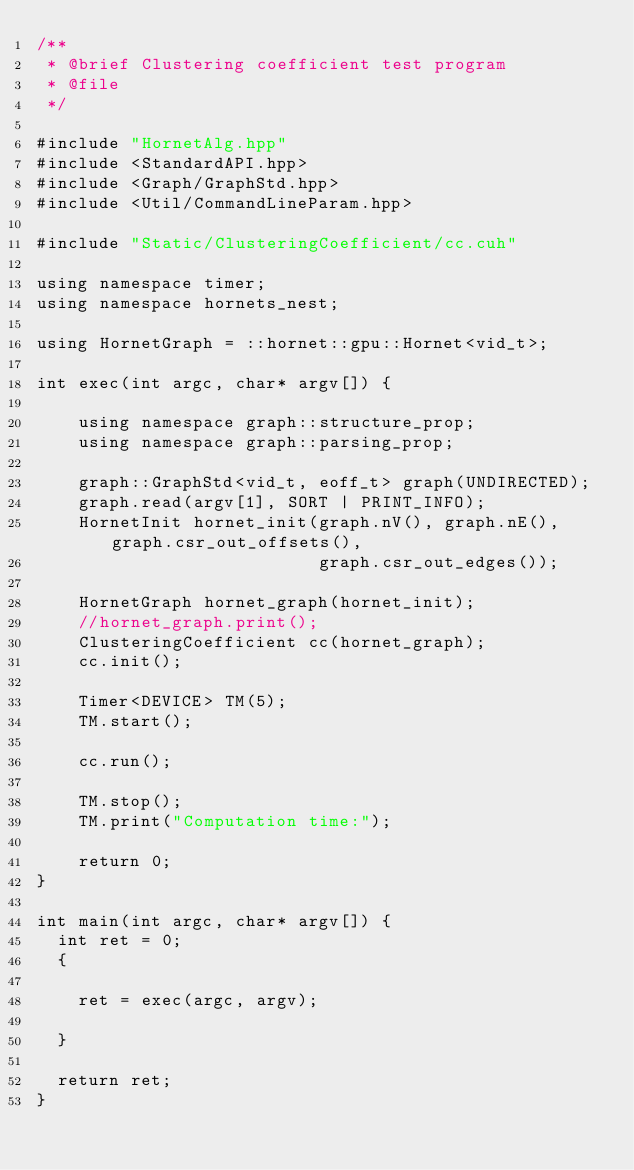Convert code to text. <code><loc_0><loc_0><loc_500><loc_500><_Cuda_>/**
 * @brief Clustering coefficient test program
 * @file
 */

#include "HornetAlg.hpp"
#include <StandardAPI.hpp>
#include <Graph/GraphStd.hpp>
#include <Util/CommandLineParam.hpp>

#include "Static/ClusteringCoefficient/cc.cuh"

using namespace timer;
using namespace hornets_nest;

using HornetGraph = ::hornet::gpu::Hornet<vid_t>;

int exec(int argc, char* argv[]) {

    using namespace graph::structure_prop;
    using namespace graph::parsing_prop;

    graph::GraphStd<vid_t, eoff_t> graph(UNDIRECTED);
    graph.read(argv[1], SORT | PRINT_INFO);
    HornetInit hornet_init(graph.nV(), graph.nE(), graph.csr_out_offsets(),
                           graph.csr_out_edges());

    HornetGraph hornet_graph(hornet_init);
    //hornet_graph.print();
    ClusteringCoefficient cc(hornet_graph);
    cc.init();

    Timer<DEVICE> TM(5);
    TM.start();

    cc.run();

    TM.stop();
    TM.print("Computation time:");

    return 0;
}

int main(int argc, char* argv[]) {
  int ret = 0;
  {

    ret = exec(argc, argv);

  }

  return ret;
}
</code> 